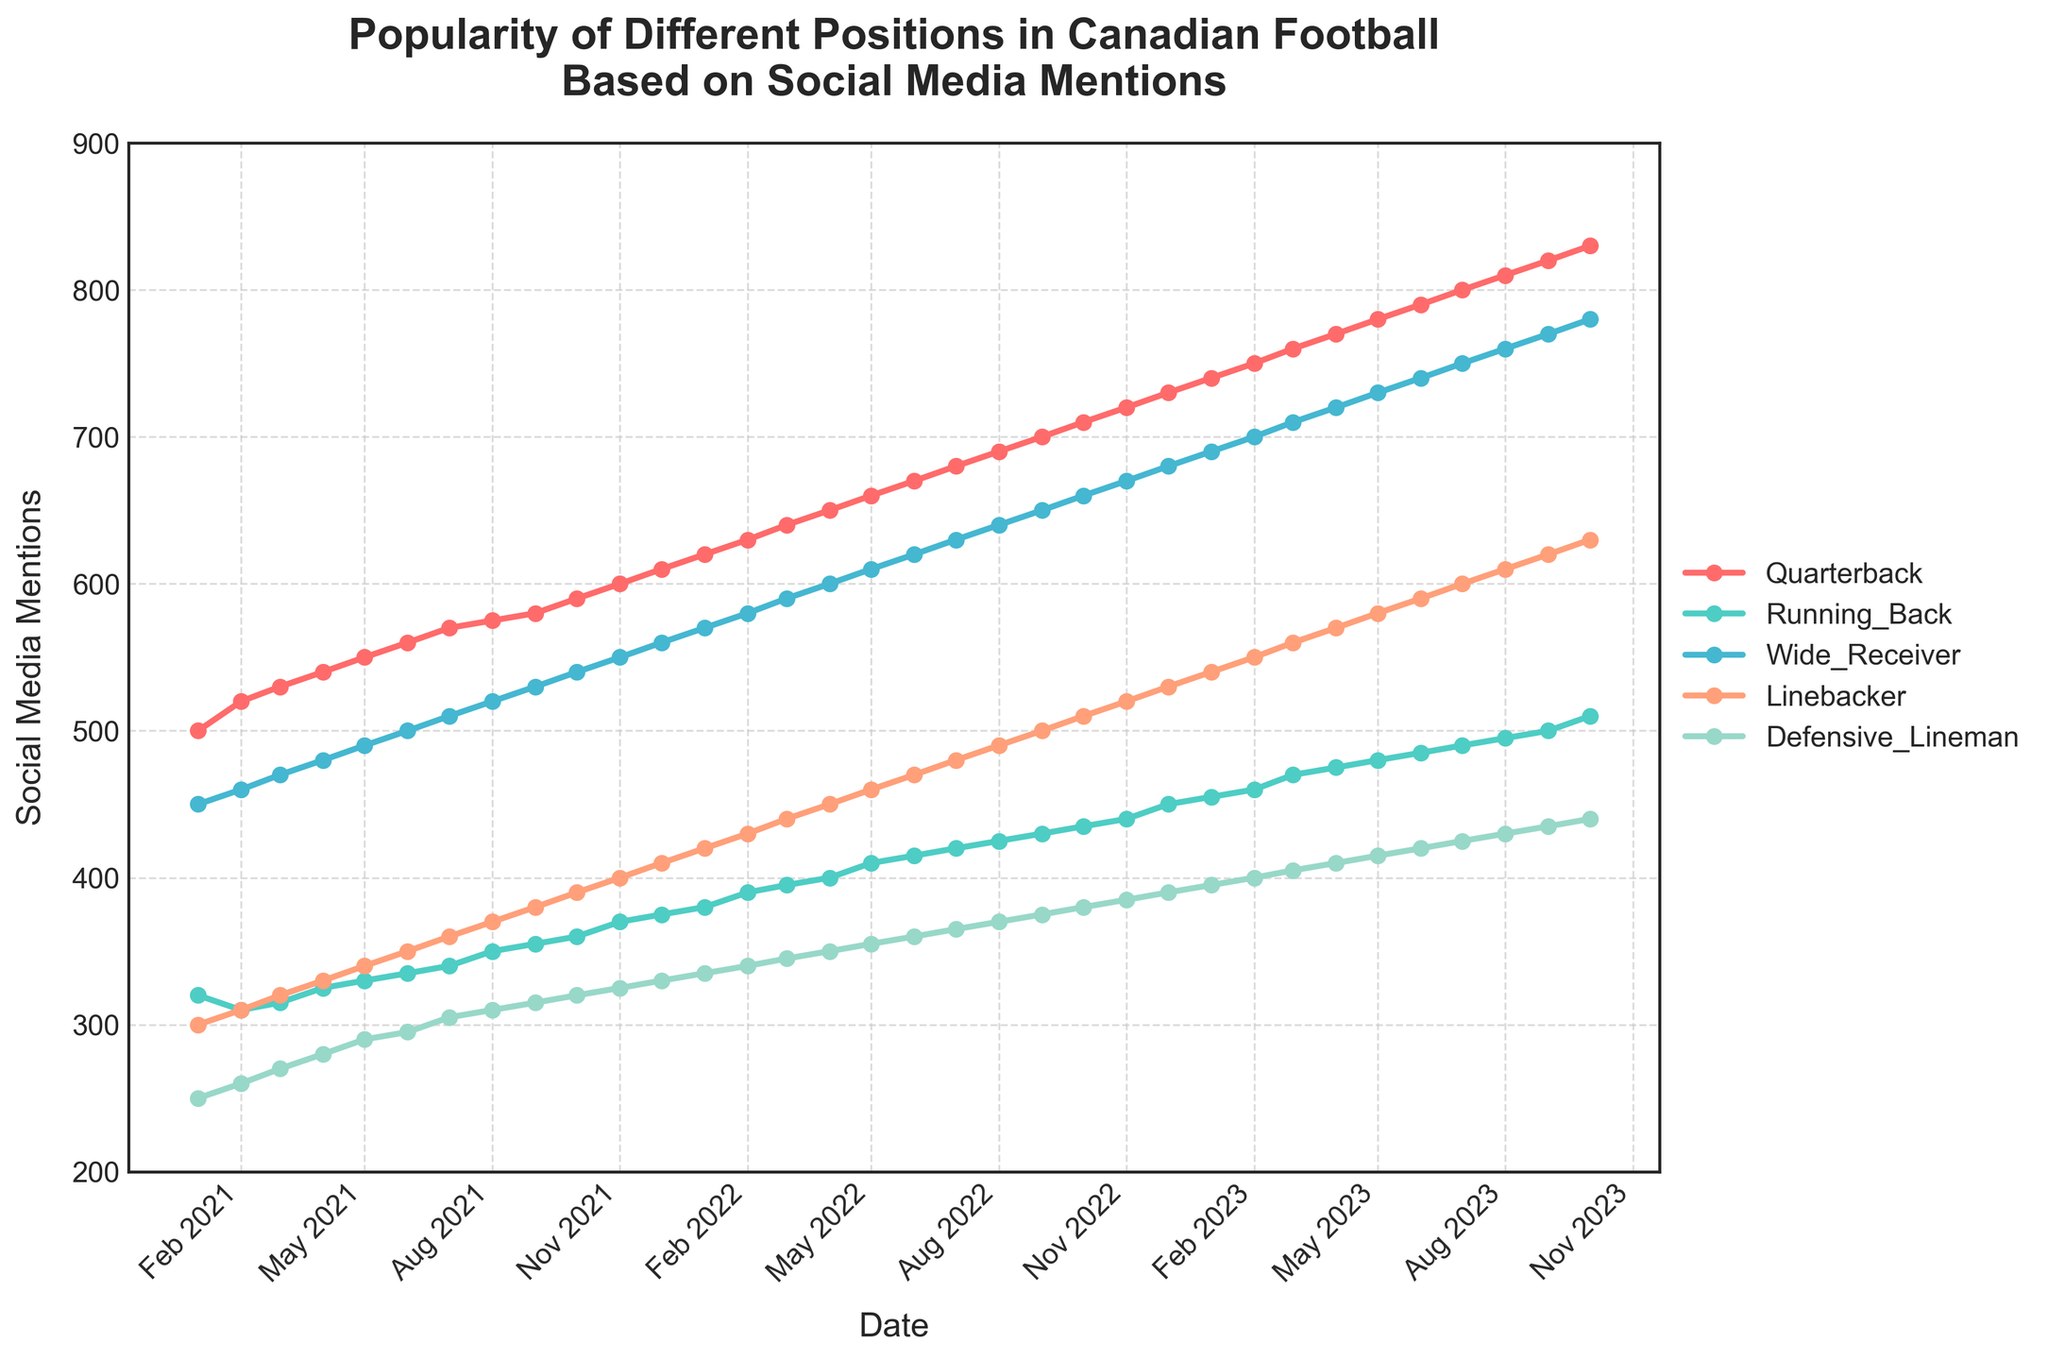what is the title of the figure? The title of the figure is displayed prominently at the top. It reads "Popularity of Different Positions in Canadian Football Based on Social Media Mentions."
Answer: Popularity of Different Positions in Canadian Football Based on Social Media Mentions What is the color used to represent the position 'Quarterback'? The position 'Quarterback' is represented by a unique color line in the plot. The color of this line is a shade of red.
Answer: Red What is the overall trend for the 'Wide Receiver' mentions from January 2021 to October 2023? The trendline for 'Wide Receiver' shows a steady increase over the period from January 2021 to October 2023. This can be seen as the markers on the line go higher and higher over time.
Answer: Increasing During which month and year was the popularity of 'Running Back' at 455 social media mentions? The 'Running Back' mentions reached 455 in January 2023, as marked on the plot.
Answer: January 2023 Which position had the highest social media mentions in October 2023, and what was the number? To find this, look at the end-point of each line in the graph at October 2023. The 'Quarterback' position had the highest mentions at 830.
Answer: Quarterback, 830 What is the average number of social media mentions for 'Linebacker' in 2021? To find the average, sum the mentions of 'Linebacker' for each month in 2021 and then divide by the number of months (12). The calculation is (300 + 310 + 320 + 330 + 340 + 350 + 360 + 370 + 380 + 390 + 400 + 410)/12 = 350.
Answer: 350 How did the social media mentions for 'Defensive Lineman' change from January 2022 to June 2022? Observe the values from January 2022 to June 2022 for 'Defensive Lineman.' The mentions went from 335 to 360, showing a steady increase.
Answer: Increased by 25 Compare the social media mentions for 'Running Back' and 'Wide Receiver' in August 2022. Which position had more mentions? Identify the specific points for 'Running Back' and 'Wide Receiver' in August 2022. 'Wide Receiver' had 640 mentions, and 'Running Back' had 425 mentions.
Answer: Wide Receiver Which position saw the greatest increase in social media mentions between January 2021 and October 2023? Measure the difference between the first and last data points for all positions. The 'Quarterback' position increased from 500 to 830, the largest absolute increase.
Answer: Quarterback 